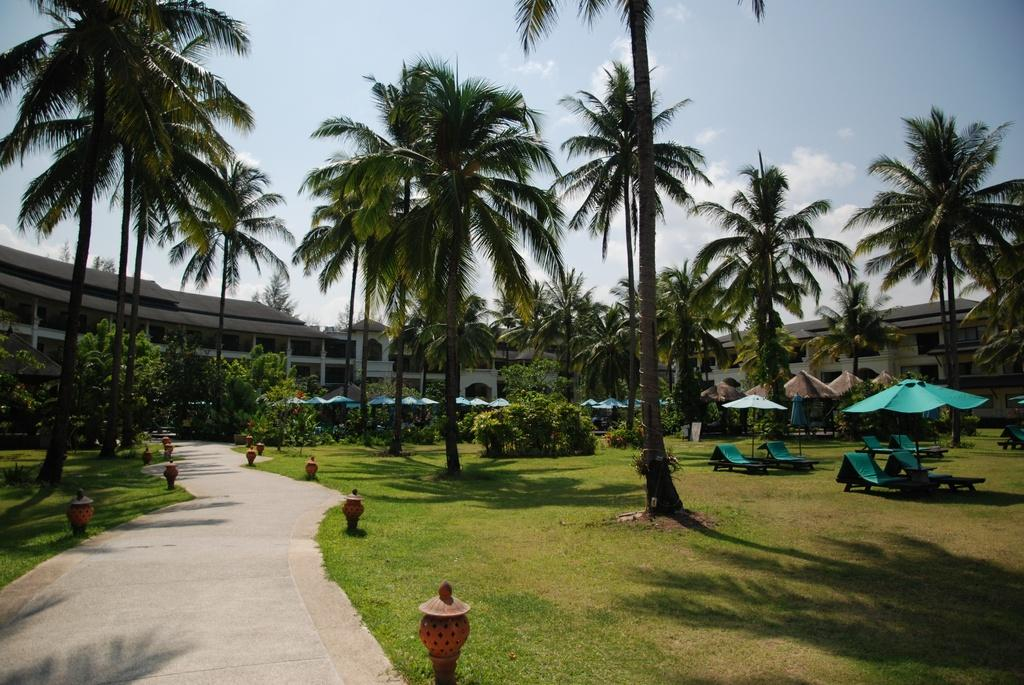What type of surface can be seen in the image? There is a road and ground visible in the image. What structures are located to the right of the image? There are tents and beach-beds to the right of the image. What can be seen in the background of the image? There are many trees, buildings, clouds, and the sky visible in the background of the image. What time of day is it in the image, given the presence of morning light? The presence of clouds and the sky in the background suggests that it is not morning, as there is no indication of morning light in the image. 